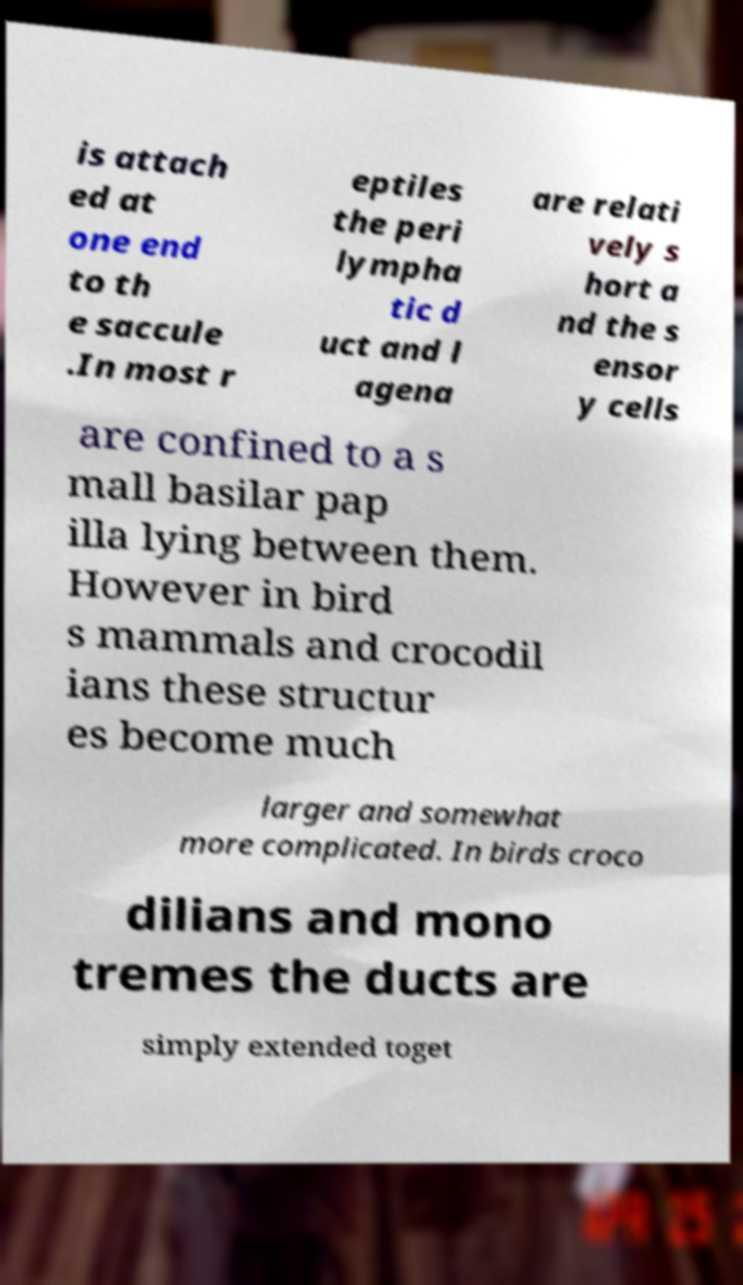Can you accurately transcribe the text from the provided image for me? is attach ed at one end to th e saccule .In most r eptiles the peri lympha tic d uct and l agena are relati vely s hort a nd the s ensor y cells are confined to a s mall basilar pap illa lying between them. However in bird s mammals and crocodil ians these structur es become much larger and somewhat more complicated. In birds croco dilians and mono tremes the ducts are simply extended toget 